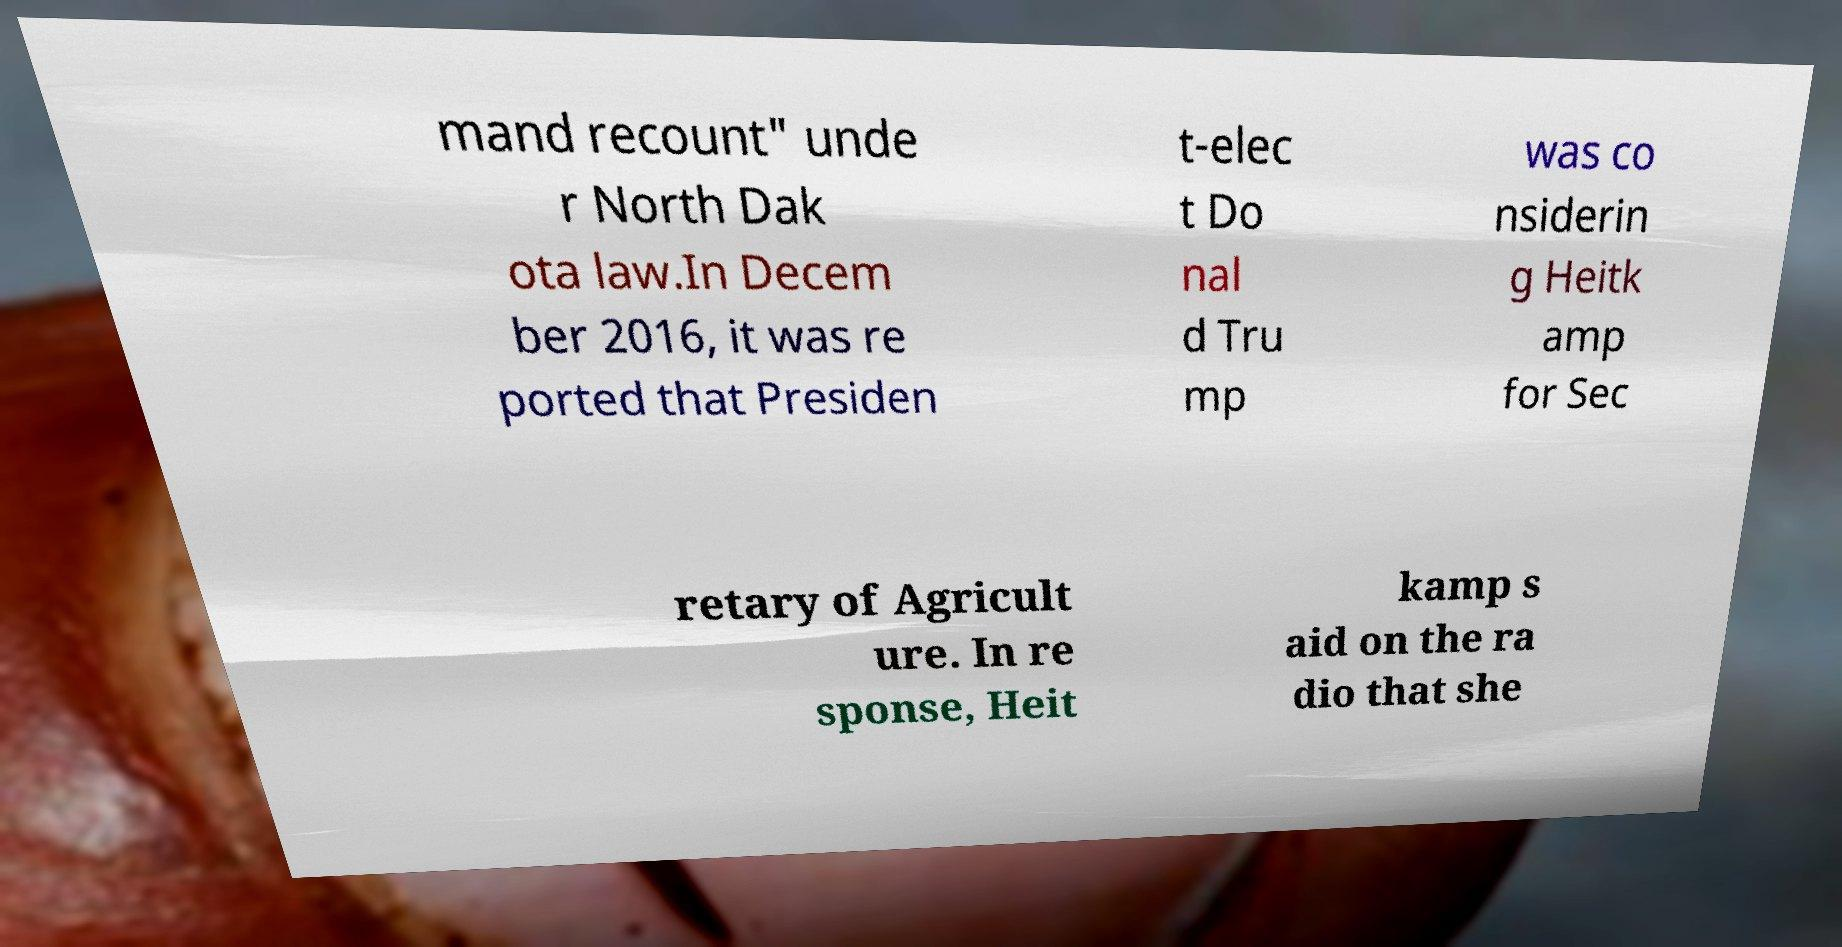Can you read and provide the text displayed in the image?This photo seems to have some interesting text. Can you extract and type it out for me? mand recount" unde r North Dak ota law.In Decem ber 2016, it was re ported that Presiden t-elec t Do nal d Tru mp was co nsiderin g Heitk amp for Sec retary of Agricult ure. In re sponse, Heit kamp s aid on the ra dio that she 